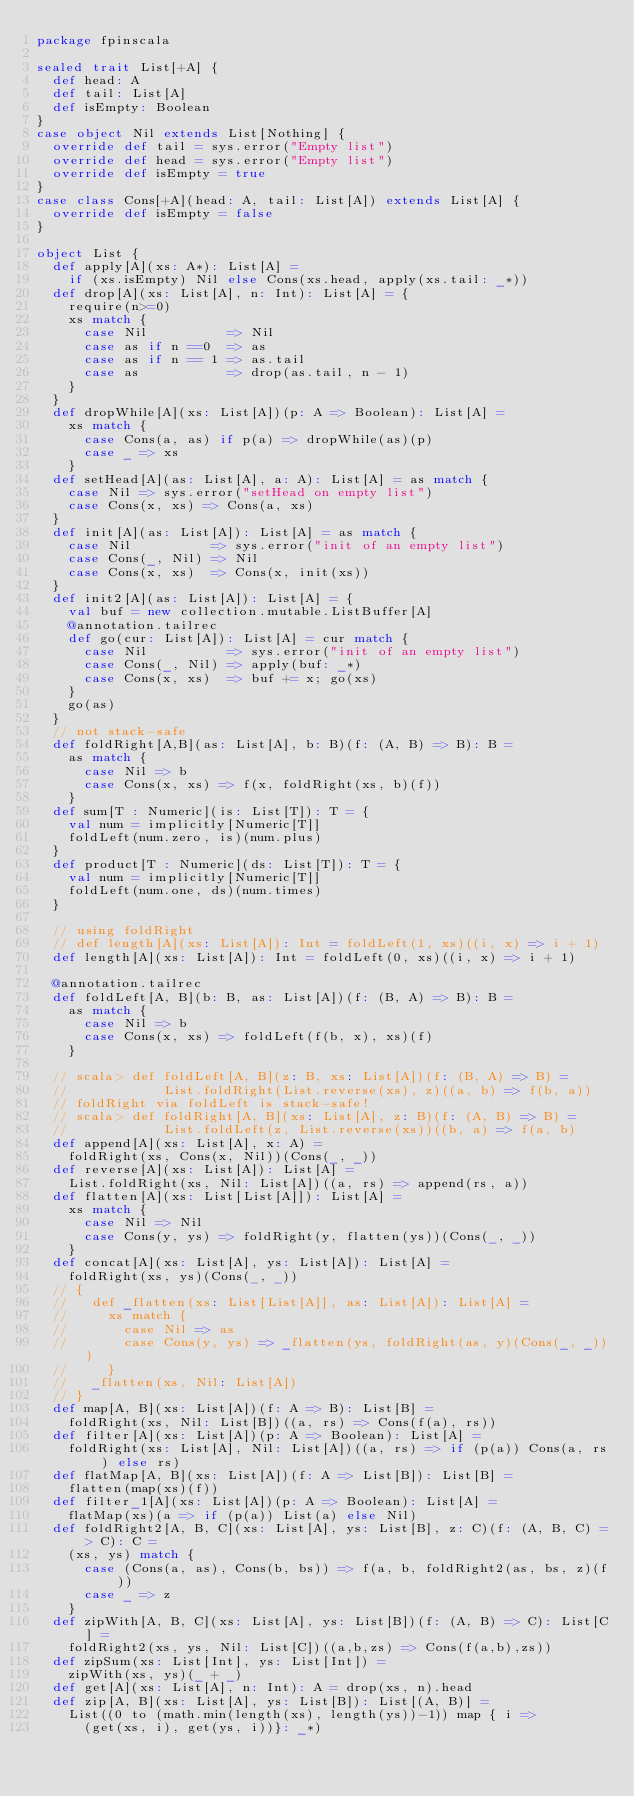Convert code to text. <code><loc_0><loc_0><loc_500><loc_500><_Scala_>package fpinscala

sealed trait List[+A] {
  def head: A
  def tail: List[A]
  def isEmpty: Boolean
}
case object Nil extends List[Nothing] {
  override def tail = sys.error("Empty list")
  override def head = sys.error("Empty list")
  override def isEmpty = true
}
case class Cons[+A](head: A, tail: List[A]) extends List[A] {
  override def isEmpty = false
}

object List {
  def apply[A](xs: A*): List[A] =
    if (xs.isEmpty) Nil else Cons(xs.head, apply(xs.tail: _*))
  def drop[A](xs: List[A], n: Int): List[A] = {
    require(n>=0)
    xs match {
      case Nil          => Nil
      case as if n ==0  => as
      case as if n == 1 => as.tail
      case as           => drop(as.tail, n - 1)
    }
  }
  def dropWhile[A](xs: List[A])(p: A => Boolean): List[A] =
    xs match {
      case Cons(a, as) if p(a) => dropWhile(as)(p)
      case _ => xs
    }
  def setHead[A](as: List[A], a: A): List[A] = as match {
    case Nil => sys.error("setHead on empty list")
    case Cons(x, xs) => Cons(a, xs)
  }
  def init[A](as: List[A]): List[A] = as match {
    case Nil          => sys.error("init of an empty list")
    case Cons(_, Nil) => Nil
    case Cons(x, xs)  => Cons(x, init(xs))
  }
  def init2[A](as: List[A]): List[A] = {
    val buf = new collection.mutable.ListBuffer[A]
    @annotation.tailrec
    def go(cur: List[A]): List[A] = cur match {
      case Nil          => sys.error("init of an empty list")
      case Cons(_, Nil) => apply(buf: _*)
      case Cons(x, xs)  => buf += x; go(xs)
    }
    go(as)
  }
  // not stack-safe
  def foldRight[A,B](as: List[A], b: B)(f: (A, B) => B): B =
    as match {
      case Nil => b
      case Cons(x, xs) => f(x, foldRight(xs, b)(f))
    }
  def sum[T : Numeric](is: List[T]): T = {
    val num = implicitly[Numeric[T]]
    foldLeft(num.zero, is)(num.plus)
  }
  def product[T : Numeric](ds: List[T]): T = {
    val num = implicitly[Numeric[T]]
    foldLeft(num.one, ds)(num.times)
  }

  // using foldRight
  // def length[A](xs: List[A]): Int = foldLeft(1, xs)((i, x) => i + 1)
  def length[A](xs: List[A]): Int = foldLeft(0, xs)((i, x) => i + 1)

  @annotation.tailrec
  def foldLeft[A, B](b: B, as: List[A])(f: (B, A) => B): B =
    as match {
      case Nil => b
      case Cons(x, xs) => foldLeft(f(b, x), xs)(f)
    }

  // scala> def foldLeft[A, B](z: B, xs: List[A])(f: (B, A) => B) =
  //            List.foldRight(List.reverse(xs), z)((a, b) => f(b, a))
  // foldRight via foldLeft is stack-safe!
  // scala> def foldRight[A, B](xs: List[A], z: B)(f: (A, B) => B) =
  //            List.foldLeft(z, List.reverse(xs))((b, a) => f(a, b)
  def append[A](xs: List[A], x: A) =
    foldRight(xs, Cons(x, Nil))(Cons(_, _))
  def reverse[A](xs: List[A]): List[A] =
    List.foldRight(xs, Nil: List[A])((a, rs) => append(rs, a))
  def flatten[A](xs: List[List[A]]): List[A] =
    xs match {
      case Nil => Nil
      case Cons(y, ys) => foldRight(y, flatten(ys))(Cons(_, _))
    }
  def concat[A](xs: List[A], ys: List[A]): List[A] =
    foldRight(xs, ys)(Cons(_, _))
  // {
  //   def _flatten(xs: List[List[A]], as: List[A]): List[A] =
  //     xs match {
  //       case Nil => as
  //       case Cons(y, ys) => _flatten(ys, foldRight(as, y)(Cons(_, _)))
  //     }
  //   _flatten(xs, Nil: List[A])
  // }
  def map[A, B](xs: List[A])(f: A => B): List[B] =
    foldRight(xs, Nil: List[B])((a, rs) => Cons(f(a), rs))
  def filter[A](xs: List[A])(p: A => Boolean): List[A] =
    foldRight(xs: List[A], Nil: List[A])((a, rs) => if (p(a)) Cons(a, rs) else rs)
  def flatMap[A, B](xs: List[A])(f: A => List[B]): List[B] =
    flatten(map(xs)(f))
  def filter_1[A](xs: List[A])(p: A => Boolean): List[A] =
    flatMap(xs)(a => if (p(a)) List(a) else Nil)
  def foldRight2[A, B, C](xs: List[A], ys: List[B], z: C)(f: (A, B, C) => C): C =
    (xs, ys) match {
      case (Cons(a, as), Cons(b, bs)) => f(a, b, foldRight2(as, bs, z)(f))
      case _ => z
    }
  def zipWith[A, B, C](xs: List[A], ys: List[B])(f: (A, B) => C): List[C] =
    foldRight2(xs, ys, Nil: List[C])((a,b,zs) => Cons(f(a,b),zs))
  def zipSum(xs: List[Int], ys: List[Int]) =
    zipWith(xs, ys)(_ + _)
  def get[A](xs: List[A], n: Int): A = drop(xs, n).head
  def zip[A, B](xs: List[A], ys: List[B]): List[(A, B)] =
    List((0 to (math.min(length(xs), length(ys))-1)) map { i =>
      (get(xs, i), get(ys, i))}: _*)</code> 